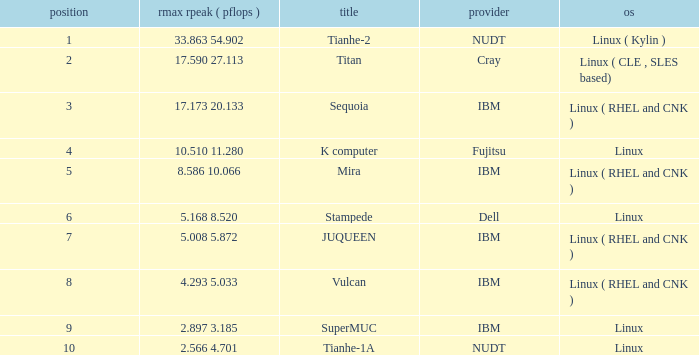What is the rank of Rmax Rpeak ( Pflops ) of 17.173 20.133? 3.0. 